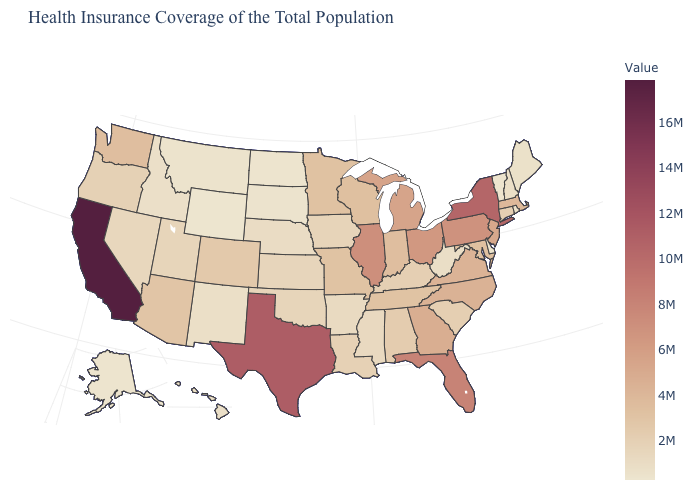Among the states that border Pennsylvania , does Maryland have the lowest value?
Be succinct. No. Which states have the lowest value in the Northeast?
Concise answer only. Vermont. Does Minnesota have the lowest value in the MidWest?
Answer briefly. No. Which states have the highest value in the USA?
Give a very brief answer. California. Does Maryland have a higher value than New York?
Write a very short answer. No. 